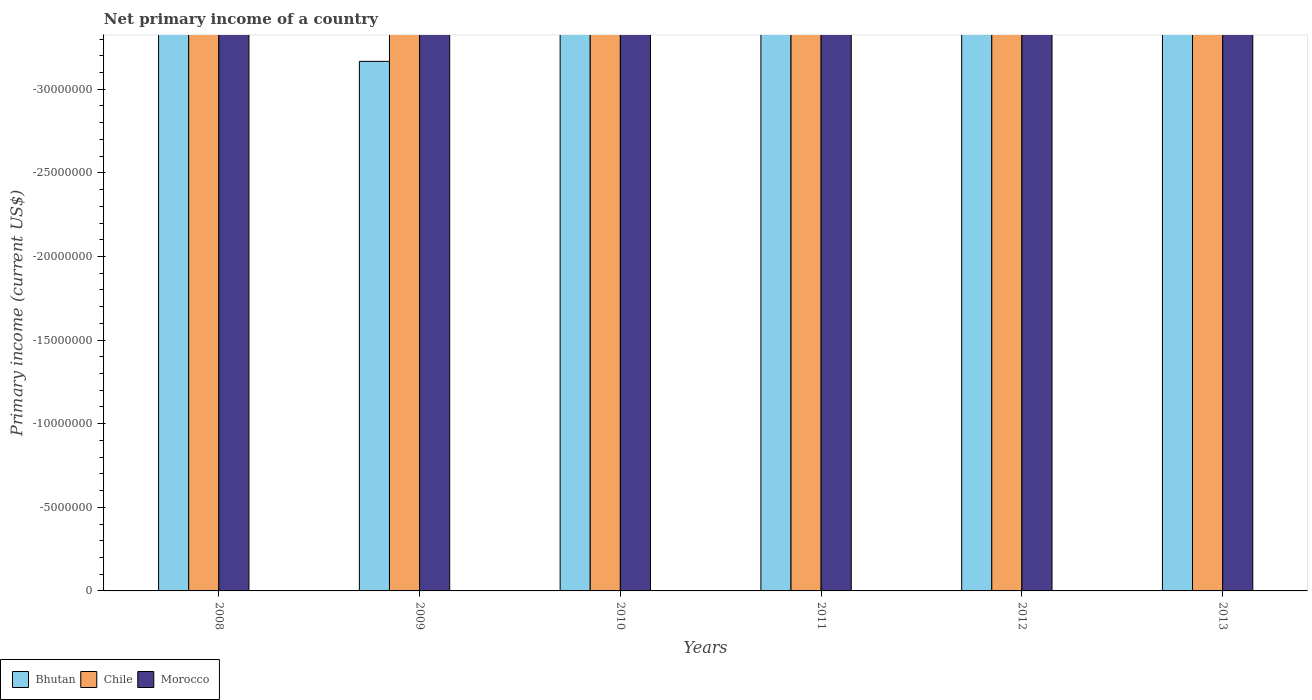How many different coloured bars are there?
Provide a short and direct response. 0. Are the number of bars on each tick of the X-axis equal?
Provide a succinct answer. Yes. In how many cases, is the number of bars for a given year not equal to the number of legend labels?
Give a very brief answer. 6. What is the primary income in Morocco in 2011?
Ensure brevity in your answer.  0. Across all years, what is the minimum primary income in Morocco?
Your response must be concise. 0. What is the total primary income in Bhutan in the graph?
Provide a short and direct response. 0. What is the difference between the primary income in Bhutan in 2009 and the primary income in Morocco in 2013?
Your response must be concise. 0. What is the average primary income in Morocco per year?
Make the answer very short. 0. In how many years, is the primary income in Bhutan greater than -7000000 US$?
Ensure brevity in your answer.  0. In how many years, is the primary income in Bhutan greater than the average primary income in Bhutan taken over all years?
Provide a short and direct response. 0. How many bars are there?
Your answer should be very brief. 0. How many years are there in the graph?
Your answer should be very brief. 6. Does the graph contain grids?
Ensure brevity in your answer.  No. Where does the legend appear in the graph?
Offer a terse response. Bottom left. How many legend labels are there?
Your answer should be compact. 3. How are the legend labels stacked?
Provide a succinct answer. Horizontal. What is the title of the graph?
Your answer should be compact. Net primary income of a country. Does "St. Lucia" appear as one of the legend labels in the graph?
Your response must be concise. No. What is the label or title of the X-axis?
Your answer should be compact. Years. What is the label or title of the Y-axis?
Make the answer very short. Primary income (current US$). What is the Primary income (current US$) in Chile in 2008?
Offer a very short reply. 0. What is the Primary income (current US$) in Morocco in 2008?
Offer a terse response. 0. What is the Primary income (current US$) in Bhutan in 2010?
Provide a short and direct response. 0. What is the Primary income (current US$) of Morocco in 2010?
Your answer should be very brief. 0. What is the Primary income (current US$) in Morocco in 2011?
Offer a very short reply. 0. What is the Primary income (current US$) in Chile in 2012?
Offer a very short reply. 0. What is the Primary income (current US$) in Morocco in 2012?
Provide a short and direct response. 0. What is the Primary income (current US$) in Bhutan in 2013?
Your answer should be very brief. 0. What is the Primary income (current US$) in Morocco in 2013?
Your answer should be compact. 0. What is the total Primary income (current US$) in Morocco in the graph?
Make the answer very short. 0. What is the average Primary income (current US$) in Morocco per year?
Provide a succinct answer. 0. 